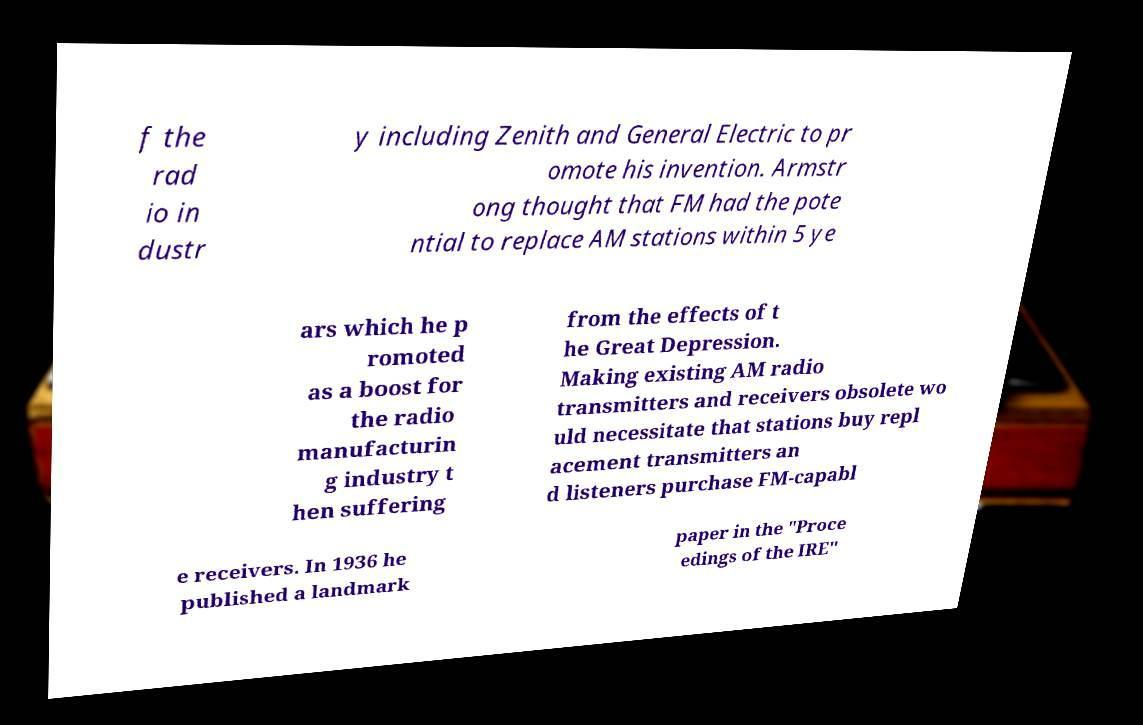Can you accurately transcribe the text from the provided image for me? f the rad io in dustr y including Zenith and General Electric to pr omote his invention. Armstr ong thought that FM had the pote ntial to replace AM stations within 5 ye ars which he p romoted as a boost for the radio manufacturin g industry t hen suffering from the effects of t he Great Depression. Making existing AM radio transmitters and receivers obsolete wo uld necessitate that stations buy repl acement transmitters an d listeners purchase FM-capabl e receivers. In 1936 he published a landmark paper in the "Proce edings of the IRE" 